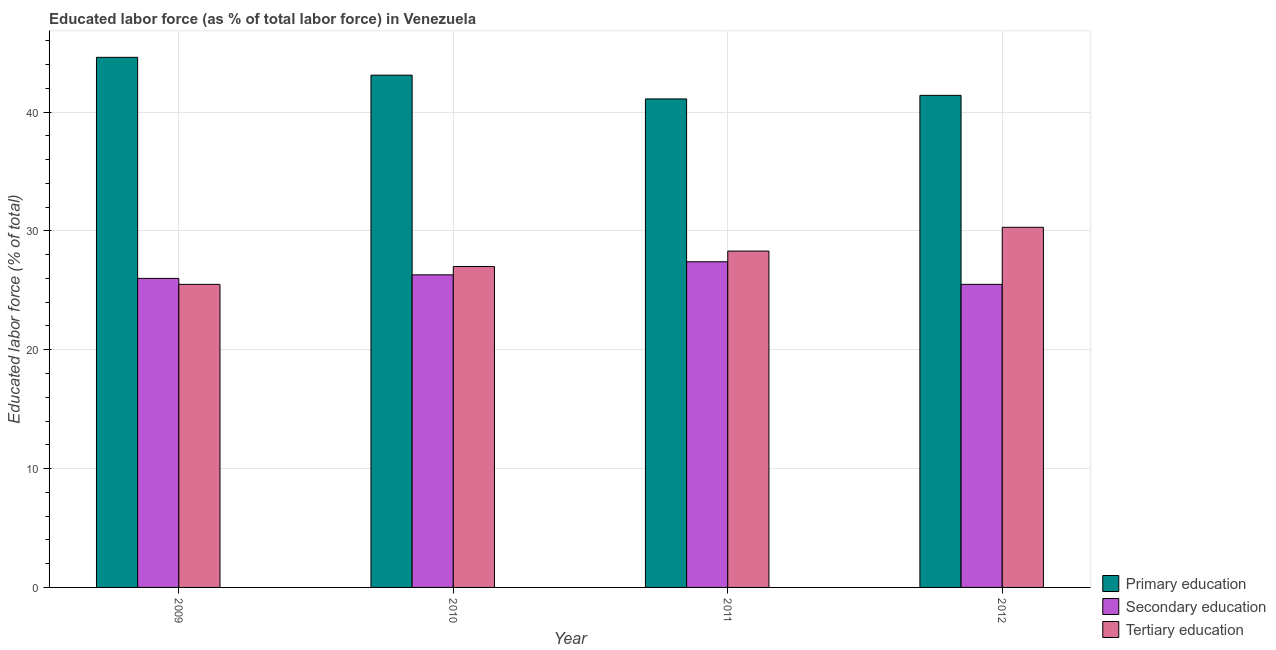How many different coloured bars are there?
Your response must be concise. 3. How many groups of bars are there?
Provide a succinct answer. 4. Are the number of bars per tick equal to the number of legend labels?
Your answer should be compact. Yes. How many bars are there on the 4th tick from the left?
Your answer should be compact. 3. What is the label of the 2nd group of bars from the left?
Provide a succinct answer. 2010. What is the percentage of labor force who received secondary education in 2010?
Provide a succinct answer. 26.3. Across all years, what is the maximum percentage of labor force who received tertiary education?
Provide a short and direct response. 30.3. In which year was the percentage of labor force who received tertiary education minimum?
Keep it short and to the point. 2009. What is the total percentage of labor force who received primary education in the graph?
Your answer should be compact. 170.2. What is the difference between the percentage of labor force who received primary education in 2009 and that in 2010?
Your response must be concise. 1.5. What is the difference between the percentage of labor force who received primary education in 2011 and the percentage of labor force who received secondary education in 2009?
Provide a short and direct response. -3.5. What is the average percentage of labor force who received tertiary education per year?
Make the answer very short. 27.77. In how many years, is the percentage of labor force who received secondary education greater than 26 %?
Ensure brevity in your answer.  2. What is the ratio of the percentage of labor force who received primary education in 2011 to that in 2012?
Offer a terse response. 0.99. Is the difference between the percentage of labor force who received primary education in 2009 and 2010 greater than the difference between the percentage of labor force who received secondary education in 2009 and 2010?
Offer a very short reply. No. What is the difference between the highest and the second highest percentage of labor force who received primary education?
Keep it short and to the point. 1.5. What is the difference between the highest and the lowest percentage of labor force who received secondary education?
Your response must be concise. 1.9. In how many years, is the percentage of labor force who received primary education greater than the average percentage of labor force who received primary education taken over all years?
Provide a short and direct response. 2. What does the 1st bar from the left in 2009 represents?
Your answer should be compact. Primary education. What does the 2nd bar from the right in 2012 represents?
Offer a terse response. Secondary education. How many bars are there?
Your answer should be compact. 12. Are all the bars in the graph horizontal?
Make the answer very short. No. How many years are there in the graph?
Provide a short and direct response. 4. Are the values on the major ticks of Y-axis written in scientific E-notation?
Make the answer very short. No. Does the graph contain grids?
Give a very brief answer. Yes. How many legend labels are there?
Give a very brief answer. 3. How are the legend labels stacked?
Offer a very short reply. Vertical. What is the title of the graph?
Your answer should be compact. Educated labor force (as % of total labor force) in Venezuela. Does "Fuel" appear as one of the legend labels in the graph?
Give a very brief answer. No. What is the label or title of the X-axis?
Offer a terse response. Year. What is the label or title of the Y-axis?
Your response must be concise. Educated labor force (% of total). What is the Educated labor force (% of total) of Primary education in 2009?
Ensure brevity in your answer.  44.6. What is the Educated labor force (% of total) in Primary education in 2010?
Provide a short and direct response. 43.1. What is the Educated labor force (% of total) of Secondary education in 2010?
Your response must be concise. 26.3. What is the Educated labor force (% of total) in Tertiary education in 2010?
Your answer should be very brief. 27. What is the Educated labor force (% of total) in Primary education in 2011?
Ensure brevity in your answer.  41.1. What is the Educated labor force (% of total) in Secondary education in 2011?
Provide a short and direct response. 27.4. What is the Educated labor force (% of total) of Tertiary education in 2011?
Your answer should be compact. 28.3. What is the Educated labor force (% of total) in Primary education in 2012?
Provide a succinct answer. 41.4. What is the Educated labor force (% of total) of Tertiary education in 2012?
Offer a terse response. 30.3. Across all years, what is the maximum Educated labor force (% of total) of Primary education?
Ensure brevity in your answer.  44.6. Across all years, what is the maximum Educated labor force (% of total) of Secondary education?
Your answer should be compact. 27.4. Across all years, what is the maximum Educated labor force (% of total) in Tertiary education?
Ensure brevity in your answer.  30.3. Across all years, what is the minimum Educated labor force (% of total) in Primary education?
Offer a terse response. 41.1. Across all years, what is the minimum Educated labor force (% of total) of Secondary education?
Provide a short and direct response. 25.5. What is the total Educated labor force (% of total) of Primary education in the graph?
Offer a very short reply. 170.2. What is the total Educated labor force (% of total) in Secondary education in the graph?
Make the answer very short. 105.2. What is the total Educated labor force (% of total) in Tertiary education in the graph?
Ensure brevity in your answer.  111.1. What is the difference between the Educated labor force (% of total) in Secondary education in 2009 and that in 2010?
Your answer should be compact. -0.3. What is the difference between the Educated labor force (% of total) of Primary education in 2009 and that in 2011?
Offer a terse response. 3.5. What is the difference between the Educated labor force (% of total) in Tertiary education in 2009 and that in 2011?
Make the answer very short. -2.8. What is the difference between the Educated labor force (% of total) in Tertiary education in 2009 and that in 2012?
Keep it short and to the point. -4.8. What is the difference between the Educated labor force (% of total) in Tertiary education in 2010 and that in 2011?
Your answer should be very brief. -1.3. What is the difference between the Educated labor force (% of total) of Primary education in 2010 and that in 2012?
Offer a terse response. 1.7. What is the difference between the Educated labor force (% of total) in Secondary education in 2010 and that in 2012?
Your response must be concise. 0.8. What is the difference between the Educated labor force (% of total) of Primary education in 2011 and that in 2012?
Offer a very short reply. -0.3. What is the difference between the Educated labor force (% of total) in Tertiary education in 2011 and that in 2012?
Provide a succinct answer. -2. What is the difference between the Educated labor force (% of total) in Primary education in 2009 and the Educated labor force (% of total) in Secondary education in 2010?
Your answer should be very brief. 18.3. What is the difference between the Educated labor force (% of total) of Primary education in 2009 and the Educated labor force (% of total) of Tertiary education in 2010?
Your answer should be very brief. 17.6. What is the difference between the Educated labor force (% of total) in Secondary education in 2009 and the Educated labor force (% of total) in Tertiary education in 2010?
Your answer should be very brief. -1. What is the difference between the Educated labor force (% of total) in Primary education in 2009 and the Educated labor force (% of total) in Tertiary education in 2011?
Your response must be concise. 16.3. What is the difference between the Educated labor force (% of total) of Primary education in 2009 and the Educated labor force (% of total) of Secondary education in 2012?
Offer a terse response. 19.1. What is the difference between the Educated labor force (% of total) in Primary education in 2009 and the Educated labor force (% of total) in Tertiary education in 2012?
Your answer should be compact. 14.3. What is the difference between the Educated labor force (% of total) in Secondary education in 2009 and the Educated labor force (% of total) in Tertiary education in 2012?
Provide a succinct answer. -4.3. What is the difference between the Educated labor force (% of total) of Primary education in 2010 and the Educated labor force (% of total) of Secondary education in 2011?
Provide a succinct answer. 15.7. What is the difference between the Educated labor force (% of total) of Secondary education in 2010 and the Educated labor force (% of total) of Tertiary education in 2011?
Offer a terse response. -2. What is the difference between the Educated labor force (% of total) in Primary education in 2010 and the Educated labor force (% of total) in Secondary education in 2012?
Your answer should be very brief. 17.6. What is the difference between the Educated labor force (% of total) in Primary education in 2011 and the Educated labor force (% of total) in Tertiary education in 2012?
Your response must be concise. 10.8. What is the average Educated labor force (% of total) of Primary education per year?
Provide a short and direct response. 42.55. What is the average Educated labor force (% of total) in Secondary education per year?
Provide a short and direct response. 26.3. What is the average Educated labor force (% of total) of Tertiary education per year?
Provide a short and direct response. 27.77. In the year 2009, what is the difference between the Educated labor force (% of total) in Primary education and Educated labor force (% of total) in Secondary education?
Offer a terse response. 18.6. In the year 2009, what is the difference between the Educated labor force (% of total) in Primary education and Educated labor force (% of total) in Tertiary education?
Your answer should be very brief. 19.1. In the year 2011, what is the difference between the Educated labor force (% of total) in Primary education and Educated labor force (% of total) in Secondary education?
Your answer should be very brief. 13.7. In the year 2011, what is the difference between the Educated labor force (% of total) in Primary education and Educated labor force (% of total) in Tertiary education?
Your answer should be compact. 12.8. In the year 2012, what is the difference between the Educated labor force (% of total) in Primary education and Educated labor force (% of total) in Tertiary education?
Ensure brevity in your answer.  11.1. In the year 2012, what is the difference between the Educated labor force (% of total) of Secondary education and Educated labor force (% of total) of Tertiary education?
Ensure brevity in your answer.  -4.8. What is the ratio of the Educated labor force (% of total) of Primary education in 2009 to that in 2010?
Provide a succinct answer. 1.03. What is the ratio of the Educated labor force (% of total) of Tertiary education in 2009 to that in 2010?
Your answer should be very brief. 0.94. What is the ratio of the Educated labor force (% of total) of Primary education in 2009 to that in 2011?
Your answer should be very brief. 1.09. What is the ratio of the Educated labor force (% of total) of Secondary education in 2009 to that in 2011?
Give a very brief answer. 0.95. What is the ratio of the Educated labor force (% of total) of Tertiary education in 2009 to that in 2011?
Make the answer very short. 0.9. What is the ratio of the Educated labor force (% of total) of Primary education in 2009 to that in 2012?
Keep it short and to the point. 1.08. What is the ratio of the Educated labor force (% of total) in Secondary education in 2009 to that in 2012?
Give a very brief answer. 1.02. What is the ratio of the Educated labor force (% of total) in Tertiary education in 2009 to that in 2012?
Make the answer very short. 0.84. What is the ratio of the Educated labor force (% of total) of Primary education in 2010 to that in 2011?
Offer a terse response. 1.05. What is the ratio of the Educated labor force (% of total) of Secondary education in 2010 to that in 2011?
Ensure brevity in your answer.  0.96. What is the ratio of the Educated labor force (% of total) of Tertiary education in 2010 to that in 2011?
Give a very brief answer. 0.95. What is the ratio of the Educated labor force (% of total) of Primary education in 2010 to that in 2012?
Your answer should be compact. 1.04. What is the ratio of the Educated labor force (% of total) in Secondary education in 2010 to that in 2012?
Ensure brevity in your answer.  1.03. What is the ratio of the Educated labor force (% of total) in Tertiary education in 2010 to that in 2012?
Provide a succinct answer. 0.89. What is the ratio of the Educated labor force (% of total) in Primary education in 2011 to that in 2012?
Offer a very short reply. 0.99. What is the ratio of the Educated labor force (% of total) in Secondary education in 2011 to that in 2012?
Offer a very short reply. 1.07. What is the ratio of the Educated labor force (% of total) in Tertiary education in 2011 to that in 2012?
Give a very brief answer. 0.93. What is the difference between the highest and the second highest Educated labor force (% of total) in Primary education?
Your answer should be compact. 1.5. What is the difference between the highest and the second highest Educated labor force (% of total) in Tertiary education?
Provide a short and direct response. 2. What is the difference between the highest and the lowest Educated labor force (% of total) in Primary education?
Your answer should be compact. 3.5. 